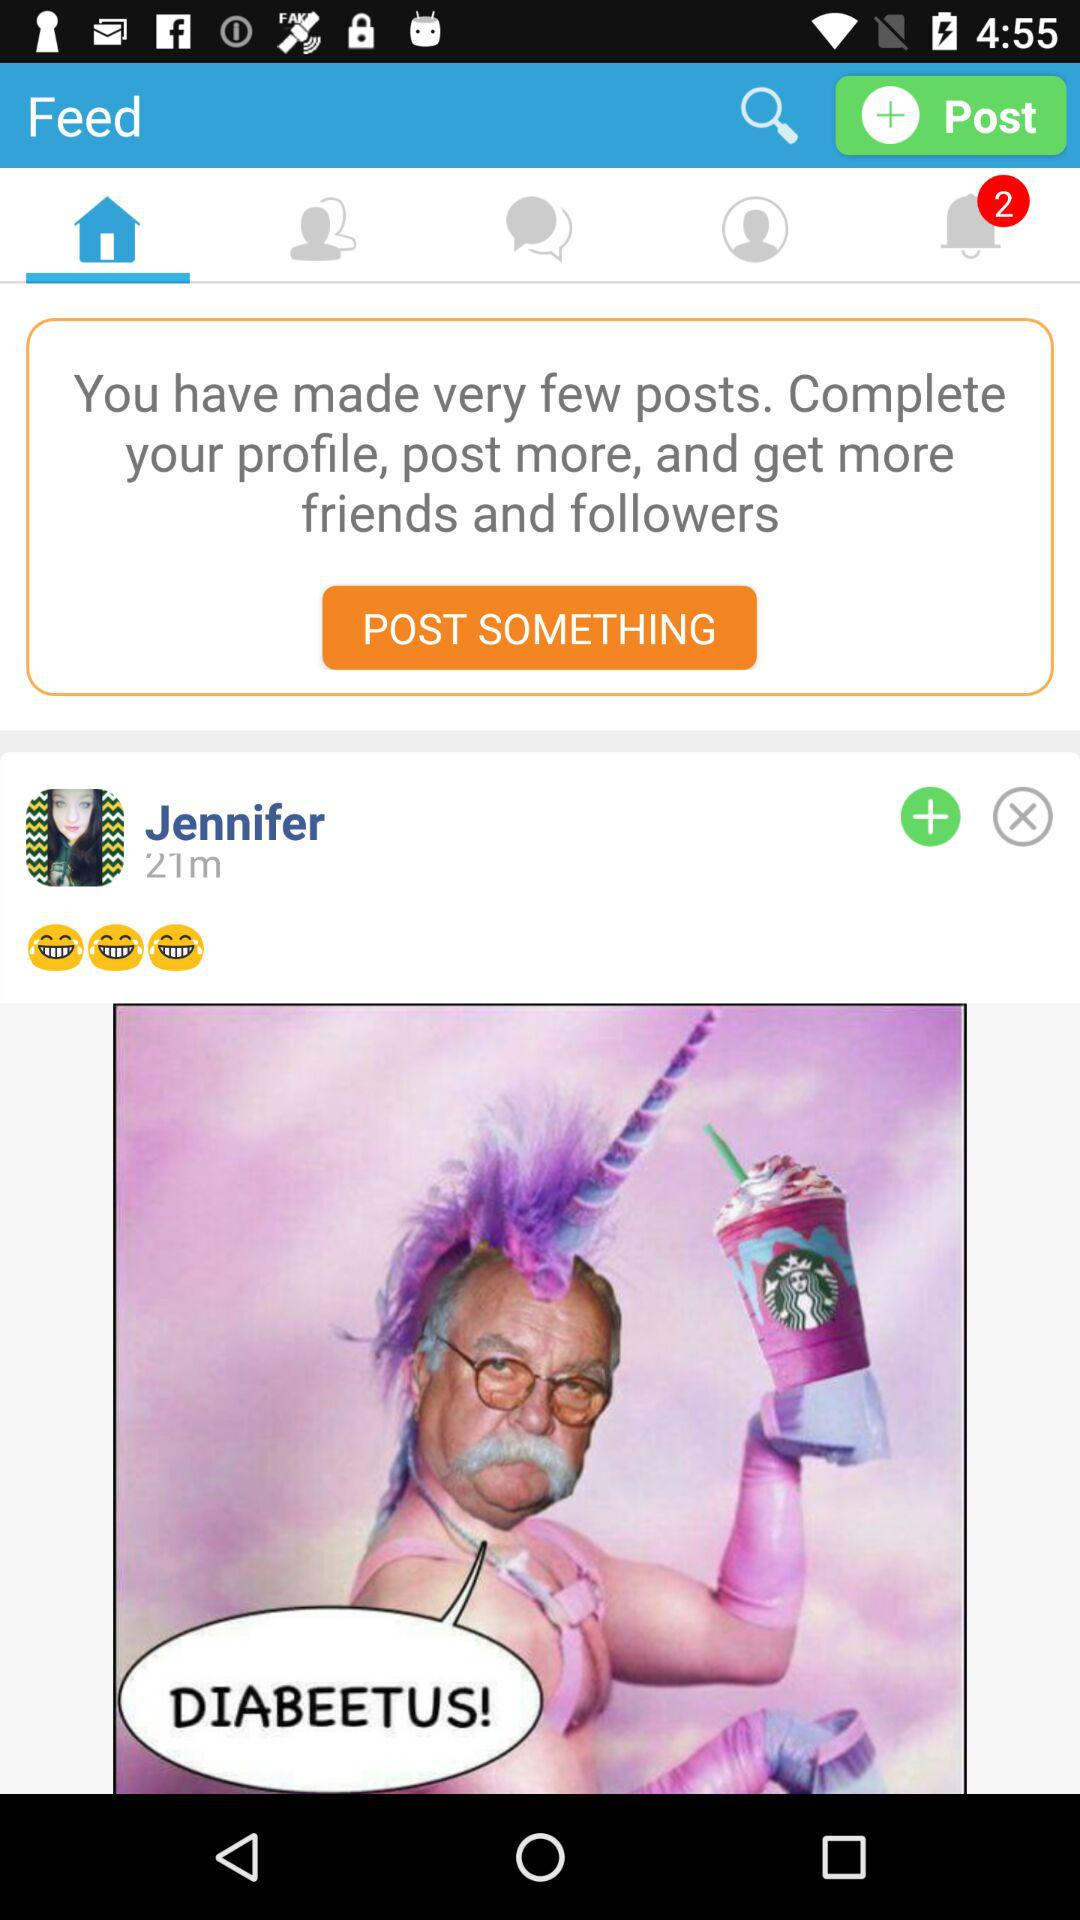How long ago was Jennifer active? Jennifer was active 21 minutes ago. 